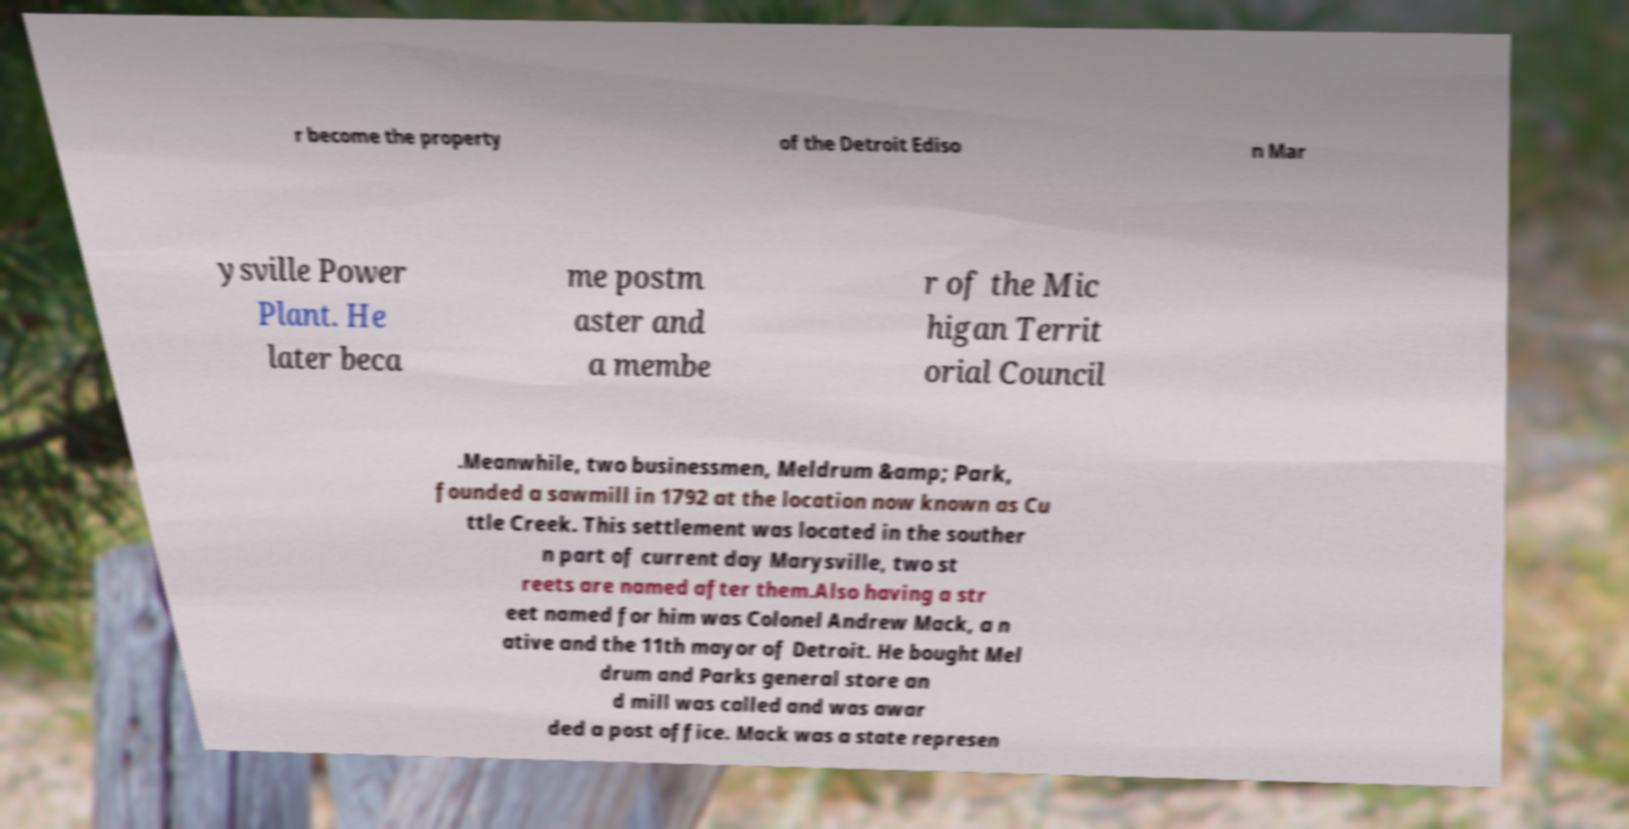Could you extract and type out the text from this image? r become the property of the Detroit Ediso n Mar ysville Power Plant. He later beca me postm aster and a membe r of the Mic higan Territ orial Council .Meanwhile, two businessmen, Meldrum &amp; Park, founded a sawmill in 1792 at the location now known as Cu ttle Creek. This settlement was located in the souther n part of current day Marysville, two st reets are named after them.Also having a str eet named for him was Colonel Andrew Mack, a n ative and the 11th mayor of Detroit. He bought Mel drum and Parks general store an d mill was called and was awar ded a post office. Mack was a state represen 